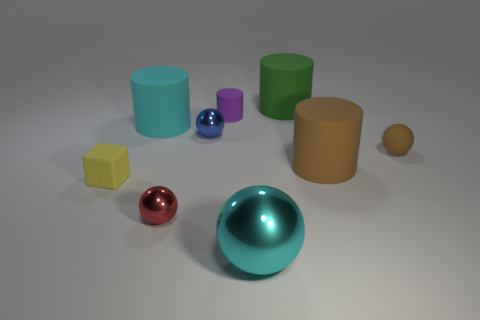There is a small brown object that is made of the same material as the green object; what shape is it?
Ensure brevity in your answer.  Sphere. Are there the same number of big metal things that are to the left of the purple matte cylinder and cyan things?
Keep it short and to the point. No. Does the cyan thing that is behind the tiny yellow rubber thing have the same material as the small sphere that is to the right of the purple cylinder?
Your response must be concise. Yes. What is the shape of the cyan object on the left side of the big ball that is to the left of the big brown rubber cylinder?
Provide a short and direct response. Cylinder. There is a small cube that is the same material as the small cylinder; what is its color?
Make the answer very short. Yellow. Does the big metal object have the same color as the tiny rubber cube?
Give a very brief answer. No. There is a brown rubber object that is the same size as the green cylinder; what shape is it?
Your answer should be compact. Cylinder. How big is the cyan matte object?
Give a very brief answer. Large. Is the size of the cyan object to the left of the large cyan shiny sphere the same as the sphere on the left side of the tiny blue metallic object?
Give a very brief answer. No. What is the color of the tiny thing in front of the small yellow block in front of the small brown object?
Ensure brevity in your answer.  Red. 